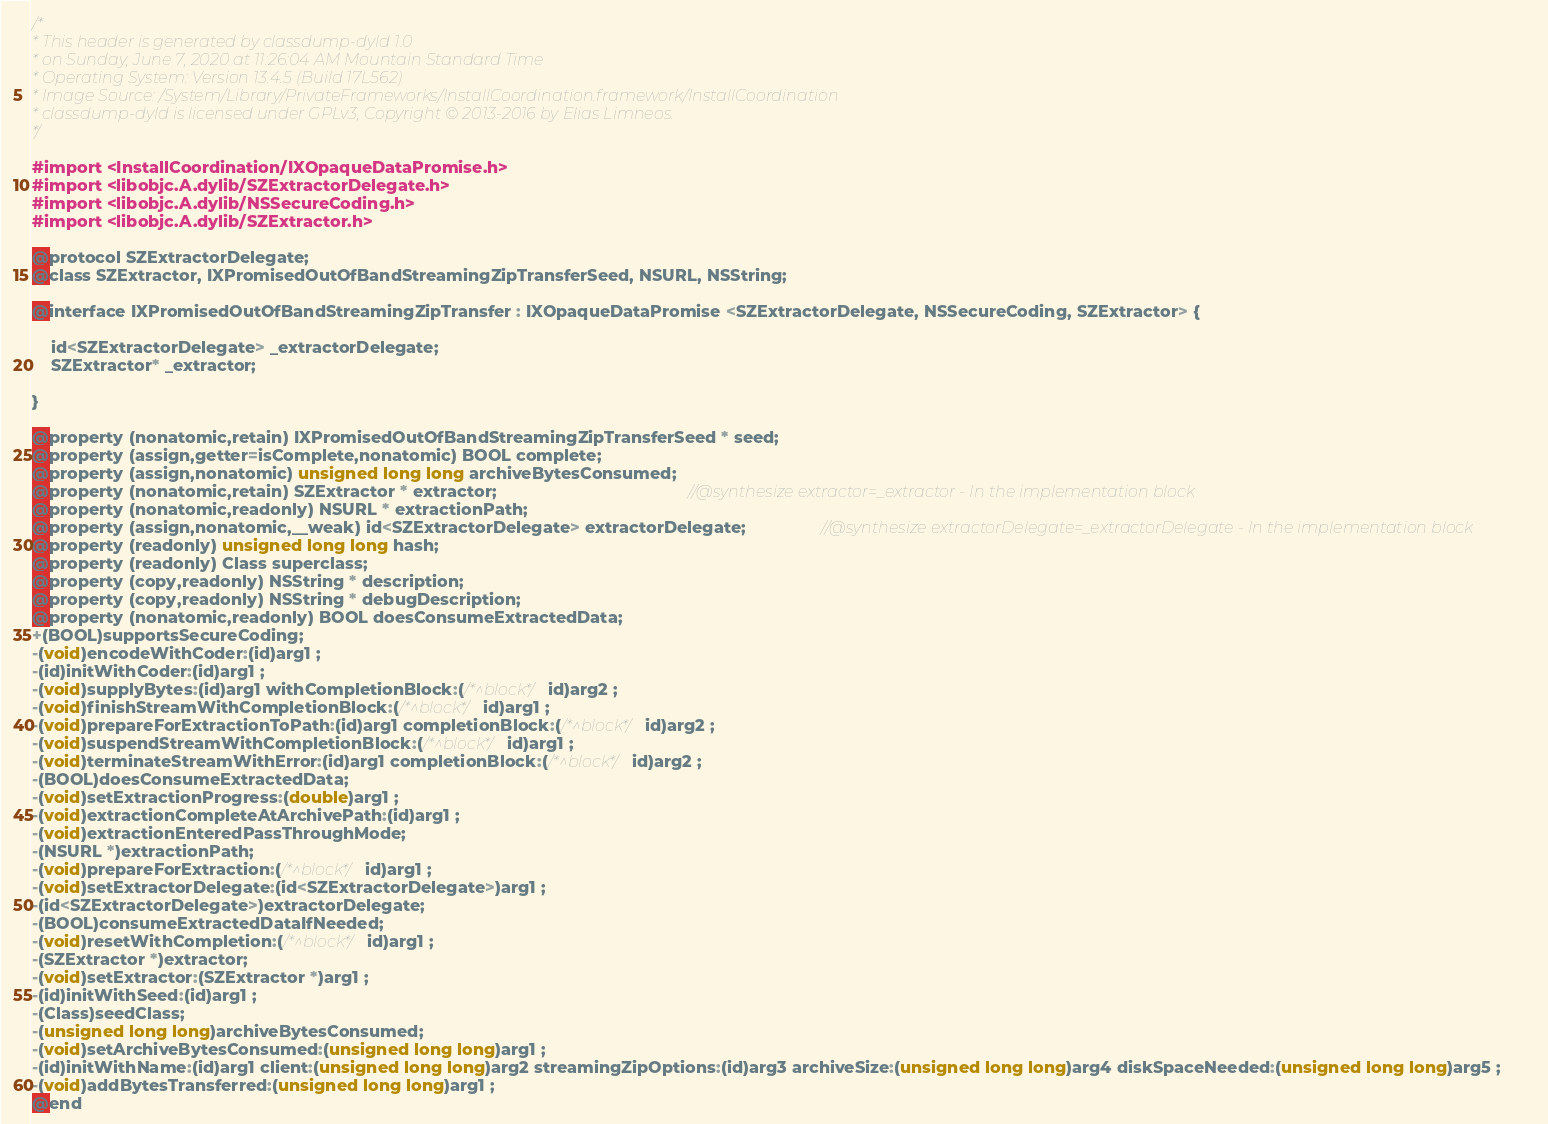Convert code to text. <code><loc_0><loc_0><loc_500><loc_500><_C_>/*
* This header is generated by classdump-dyld 1.0
* on Sunday, June 7, 2020 at 11:26:04 AM Mountain Standard Time
* Operating System: Version 13.4.5 (Build 17L562)
* Image Source: /System/Library/PrivateFrameworks/InstallCoordination.framework/InstallCoordination
* classdump-dyld is licensed under GPLv3, Copyright © 2013-2016 by Elias Limneos.
*/

#import <InstallCoordination/IXOpaqueDataPromise.h>
#import <libobjc.A.dylib/SZExtractorDelegate.h>
#import <libobjc.A.dylib/NSSecureCoding.h>
#import <libobjc.A.dylib/SZExtractor.h>

@protocol SZExtractorDelegate;
@class SZExtractor, IXPromisedOutOfBandStreamingZipTransferSeed, NSURL, NSString;

@interface IXPromisedOutOfBandStreamingZipTransfer : IXOpaqueDataPromise <SZExtractorDelegate, NSSecureCoding, SZExtractor> {

	id<SZExtractorDelegate> _extractorDelegate;
	SZExtractor* _extractor;

}

@property (nonatomic,retain) IXPromisedOutOfBandStreamingZipTransferSeed * seed; 
@property (assign,getter=isComplete,nonatomic) BOOL complete; 
@property (assign,nonatomic) unsigned long long archiveBytesConsumed; 
@property (nonatomic,retain) SZExtractor * extractor;                                         //@synthesize extractor=_extractor - In the implementation block
@property (nonatomic,readonly) NSURL * extractionPath; 
@property (assign,nonatomic,__weak) id<SZExtractorDelegate> extractorDelegate;                //@synthesize extractorDelegate=_extractorDelegate - In the implementation block
@property (readonly) unsigned long long hash; 
@property (readonly) Class superclass; 
@property (copy,readonly) NSString * description; 
@property (copy,readonly) NSString * debugDescription; 
@property (nonatomic,readonly) BOOL doesConsumeExtractedData; 
+(BOOL)supportsSecureCoding;
-(void)encodeWithCoder:(id)arg1 ;
-(id)initWithCoder:(id)arg1 ;
-(void)supplyBytes:(id)arg1 withCompletionBlock:(/*^block*/id)arg2 ;
-(void)finishStreamWithCompletionBlock:(/*^block*/id)arg1 ;
-(void)prepareForExtractionToPath:(id)arg1 completionBlock:(/*^block*/id)arg2 ;
-(void)suspendStreamWithCompletionBlock:(/*^block*/id)arg1 ;
-(void)terminateStreamWithError:(id)arg1 completionBlock:(/*^block*/id)arg2 ;
-(BOOL)doesConsumeExtractedData;
-(void)setExtractionProgress:(double)arg1 ;
-(void)extractionCompleteAtArchivePath:(id)arg1 ;
-(void)extractionEnteredPassThroughMode;
-(NSURL *)extractionPath;
-(void)prepareForExtraction:(/*^block*/id)arg1 ;
-(void)setExtractorDelegate:(id<SZExtractorDelegate>)arg1 ;
-(id<SZExtractorDelegate>)extractorDelegate;
-(BOOL)consumeExtractedDataIfNeeded;
-(void)resetWithCompletion:(/*^block*/id)arg1 ;
-(SZExtractor *)extractor;
-(void)setExtractor:(SZExtractor *)arg1 ;
-(id)initWithSeed:(id)arg1 ;
-(Class)seedClass;
-(unsigned long long)archiveBytesConsumed;
-(void)setArchiveBytesConsumed:(unsigned long long)arg1 ;
-(id)initWithName:(id)arg1 client:(unsigned long long)arg2 streamingZipOptions:(id)arg3 archiveSize:(unsigned long long)arg4 diskSpaceNeeded:(unsigned long long)arg5 ;
-(void)addBytesTransferred:(unsigned long long)arg1 ;
@end

</code> 